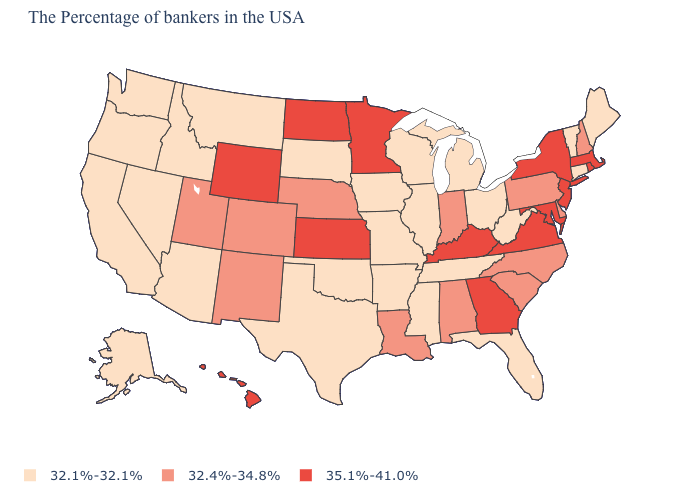Name the states that have a value in the range 32.4%-34.8%?
Be succinct. New Hampshire, Delaware, Pennsylvania, North Carolina, South Carolina, Indiana, Alabama, Louisiana, Nebraska, Colorado, New Mexico, Utah. Among the states that border Ohio , which have the lowest value?
Give a very brief answer. West Virginia, Michigan. What is the value of New Jersey?
Write a very short answer. 35.1%-41.0%. What is the value of Wisconsin?
Be succinct. 32.1%-32.1%. Name the states that have a value in the range 32.1%-32.1%?
Be succinct. Maine, Vermont, Connecticut, West Virginia, Ohio, Florida, Michigan, Tennessee, Wisconsin, Illinois, Mississippi, Missouri, Arkansas, Iowa, Oklahoma, Texas, South Dakota, Montana, Arizona, Idaho, Nevada, California, Washington, Oregon, Alaska. What is the value of Michigan?
Answer briefly. 32.1%-32.1%. Among the states that border Idaho , does Utah have the highest value?
Be succinct. No. Is the legend a continuous bar?
Write a very short answer. No. Among the states that border Tennessee , does Alabama have the highest value?
Keep it brief. No. Which states hav the highest value in the South?
Give a very brief answer. Maryland, Virginia, Georgia, Kentucky. Which states have the highest value in the USA?
Be succinct. Massachusetts, Rhode Island, New York, New Jersey, Maryland, Virginia, Georgia, Kentucky, Minnesota, Kansas, North Dakota, Wyoming, Hawaii. How many symbols are there in the legend?
Give a very brief answer. 3. Name the states that have a value in the range 35.1%-41.0%?
Concise answer only. Massachusetts, Rhode Island, New York, New Jersey, Maryland, Virginia, Georgia, Kentucky, Minnesota, Kansas, North Dakota, Wyoming, Hawaii. Which states have the lowest value in the Northeast?
Give a very brief answer. Maine, Vermont, Connecticut. Does Arkansas have a higher value than Ohio?
Quick response, please. No. 